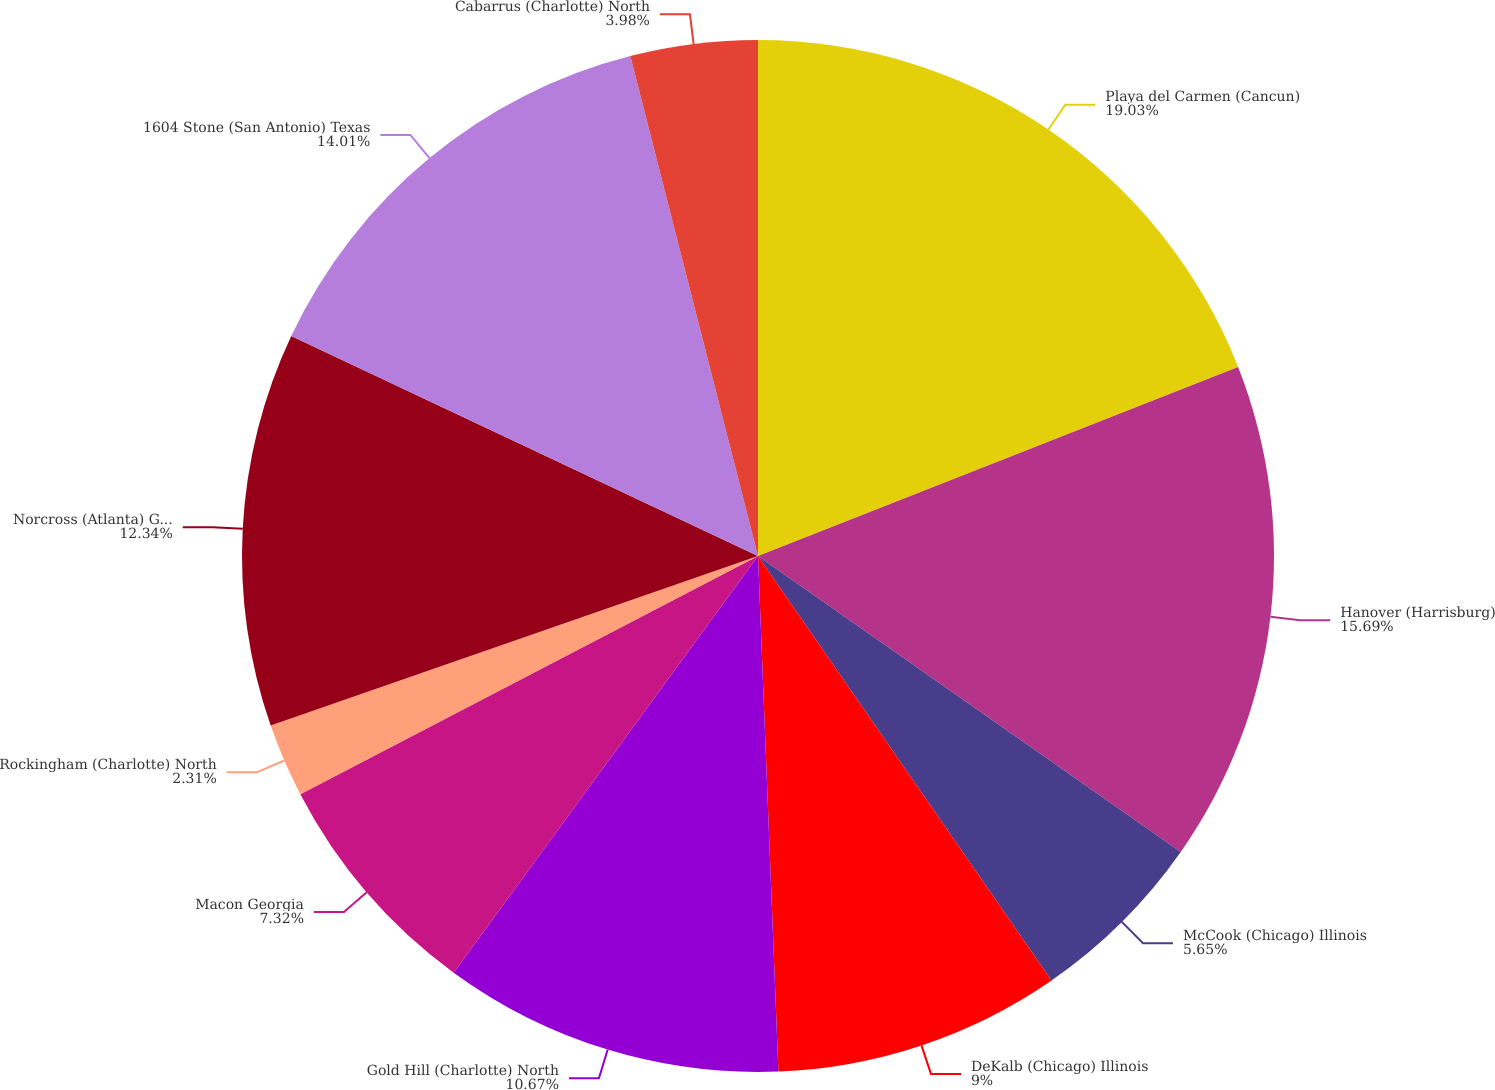<chart> <loc_0><loc_0><loc_500><loc_500><pie_chart><fcel>Playa del Carmen (Cancun)<fcel>Hanover (Harrisburg)<fcel>McCook (Chicago) Illinois<fcel>DeKalb (Chicago) Illinois<fcel>Gold Hill (Charlotte) North<fcel>Macon Georgia<fcel>Rockingham (Charlotte) North<fcel>Norcross (Atlanta) Georgia<fcel>1604 Stone (San Antonio) Texas<fcel>Cabarrus (Charlotte) North<nl><fcel>19.03%<fcel>15.69%<fcel>5.65%<fcel>9.0%<fcel>10.67%<fcel>7.32%<fcel>2.31%<fcel>12.34%<fcel>14.01%<fcel>3.98%<nl></chart> 